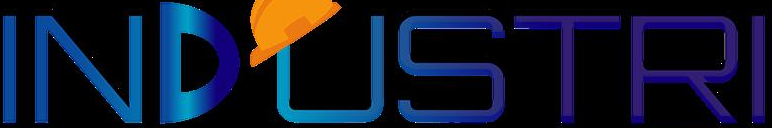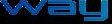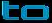Transcribe the words shown in these images in order, separated by a semicolon. INDUSTRI; way; to 